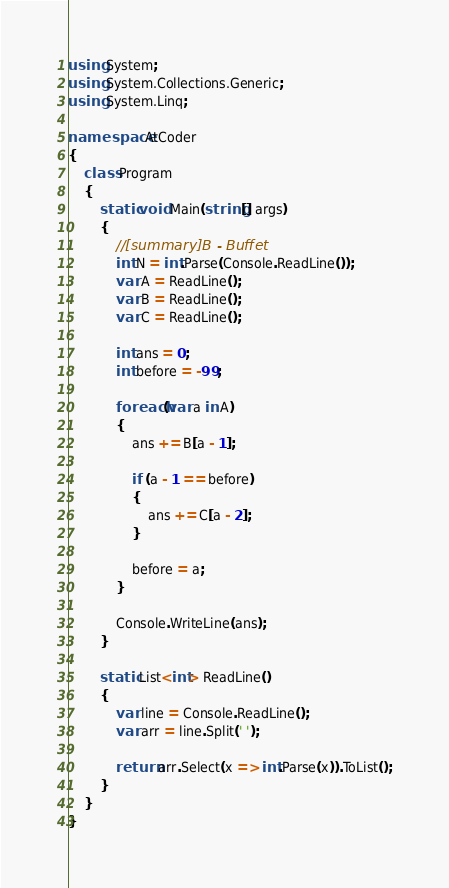<code> <loc_0><loc_0><loc_500><loc_500><_C#_>using System;
using System.Collections.Generic;
using System.Linq;

namespace AtCoder
{
    class Program
    {
        static void Main(string[] args)
        {
            //[summary]B - Buffet
            int N = int.Parse(Console.ReadLine());
            var A = ReadLine();
            var B = ReadLine();
            var C = ReadLine();

            int ans = 0;
            int before = -99;

            foreach(var a in A)
            {
                ans += B[a - 1];

                if (a - 1 == before)
                {
                    ans += C[a - 2];
                }

                before = a;
            }

            Console.WriteLine(ans);
        }

        static List<int> ReadLine()
        {
            var line = Console.ReadLine();
            var arr = line.Split(' ');

            return arr.Select(x => int.Parse(x)).ToList();
        }
    }
}</code> 